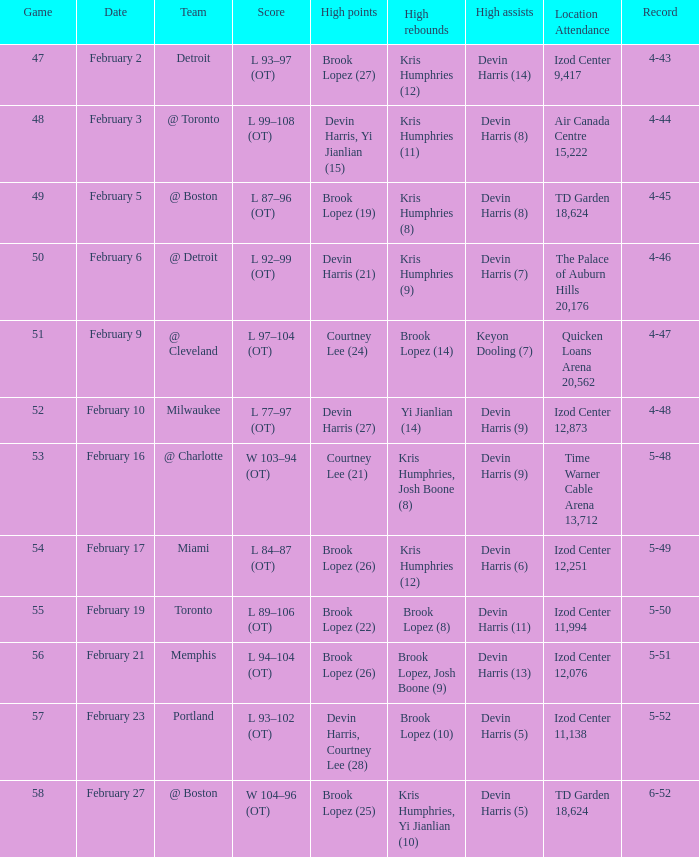What team was the game on February 27 played against? @ Boston. 